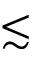<formula> <loc_0><loc_0><loc_500><loc_500>\lesssim</formula> 